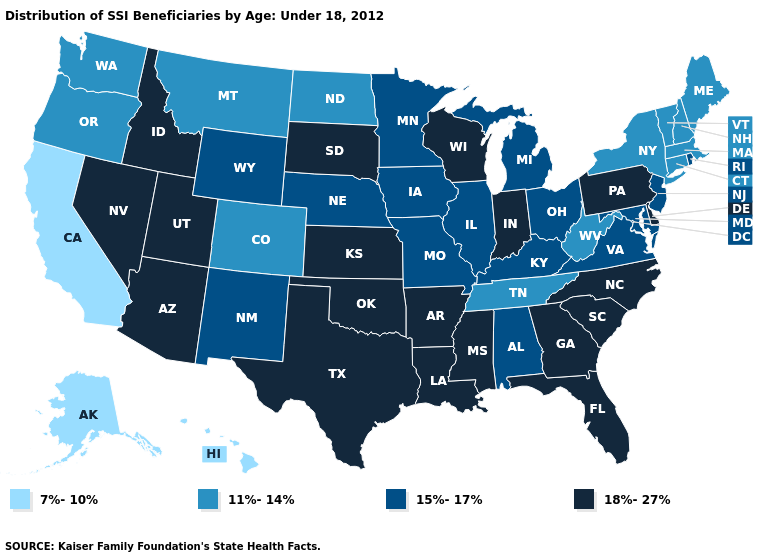Name the states that have a value in the range 11%-14%?
Keep it brief. Colorado, Connecticut, Maine, Massachusetts, Montana, New Hampshire, New York, North Dakota, Oregon, Tennessee, Vermont, Washington, West Virginia. Among the states that border North Carolina , does Virginia have the lowest value?
Answer briefly. No. What is the value of Missouri?
Short answer required. 15%-17%. Name the states that have a value in the range 15%-17%?
Quick response, please. Alabama, Illinois, Iowa, Kentucky, Maryland, Michigan, Minnesota, Missouri, Nebraska, New Jersey, New Mexico, Ohio, Rhode Island, Virginia, Wyoming. What is the value of Texas?
Write a very short answer. 18%-27%. What is the highest value in the USA?
Be succinct. 18%-27%. Does Ohio have a higher value than Texas?
Answer briefly. No. Does Oregon have the highest value in the USA?
Give a very brief answer. No. What is the value of West Virginia?
Be succinct. 11%-14%. What is the value of Hawaii?
Keep it brief. 7%-10%. Does Michigan have the highest value in the USA?
Be succinct. No. Name the states that have a value in the range 11%-14%?
Write a very short answer. Colorado, Connecticut, Maine, Massachusetts, Montana, New Hampshire, New York, North Dakota, Oregon, Tennessee, Vermont, Washington, West Virginia. How many symbols are there in the legend?
Quick response, please. 4. Name the states that have a value in the range 18%-27%?
Concise answer only. Arizona, Arkansas, Delaware, Florida, Georgia, Idaho, Indiana, Kansas, Louisiana, Mississippi, Nevada, North Carolina, Oklahoma, Pennsylvania, South Carolina, South Dakota, Texas, Utah, Wisconsin. What is the value of Montana?
Answer briefly. 11%-14%. 